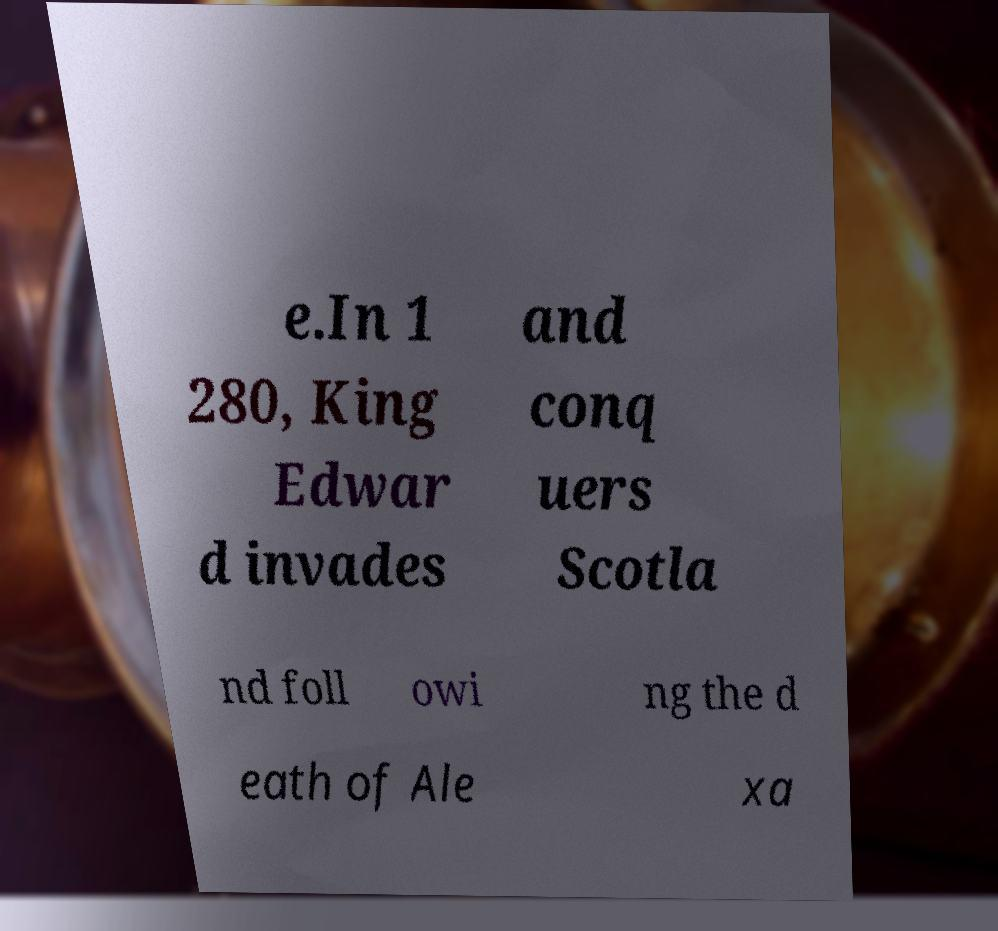Could you extract and type out the text from this image? e.In 1 280, King Edwar d invades and conq uers Scotla nd foll owi ng the d eath of Ale xa 